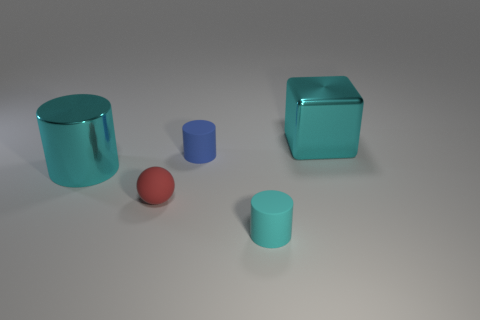What number of blue objects are the same shape as the red matte thing? None of the blue objects have the same shape as the red object, which is a sphere. The blue objects comprise two cylinders and one cube, making the distinct shapes different from that of the red object. 